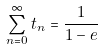<formula> <loc_0><loc_0><loc_500><loc_500>\sum _ { n = 0 } ^ { \infty } t _ { n } = \frac { 1 } { 1 - e }</formula> 